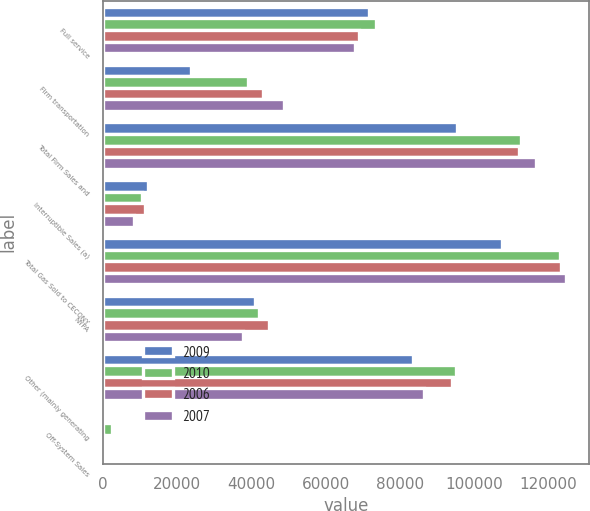Convert chart to OTSL. <chart><loc_0><loc_0><loc_500><loc_500><stacked_bar_chart><ecel><fcel>Full service<fcel>Firm transportation<fcel>Total Firm Sales and<fcel>Interruptible Sales (a)<fcel>Total Gas Sold to CECONY<fcel>NYPA<fcel>Other (mainly generating<fcel>Off-System Sales<nl><fcel>2009<fcel>71858<fcel>23688<fcel>95546<fcel>11995<fcel>107541<fcel>41057<fcel>83688<fcel>691<nl><fcel>2010<fcel>73734<fcel>39017<fcel>112751<fcel>10577<fcel>123328<fcel>42085<fcel>95260<fcel>2325<nl><fcel>2006<fcel>68943<fcel>43245<fcel>112188<fcel>11220<fcel>123408<fcel>44694<fcel>94086<fcel>154<nl><fcel>2007<fcel>67994<fcel>48671<fcel>116665<fcel>8225<fcel>124890<fcel>37764<fcel>86454<fcel>1<nl></chart> 